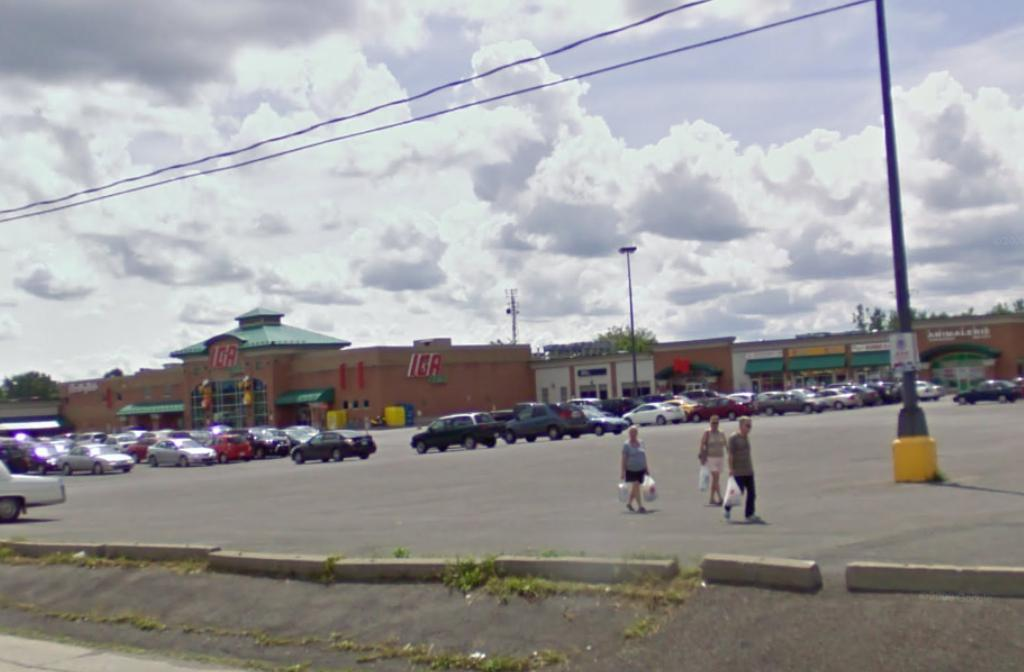<image>
Offer a succinct explanation of the picture presented. People walking in front of a building that says "IGA" on it. 